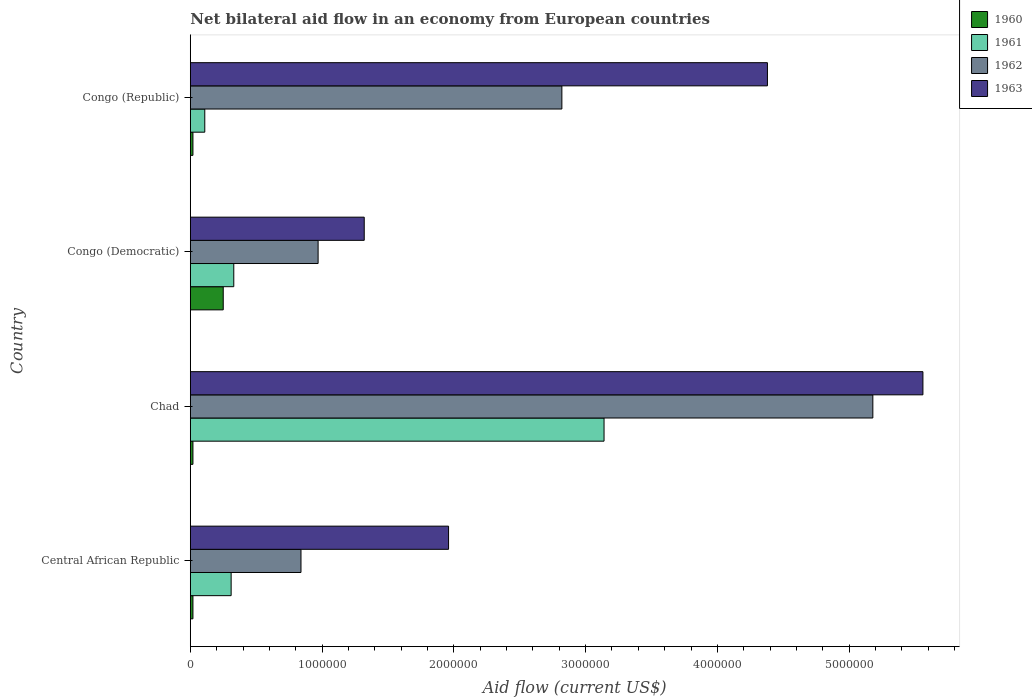How many different coloured bars are there?
Keep it short and to the point. 4. Are the number of bars per tick equal to the number of legend labels?
Your answer should be very brief. Yes. Are the number of bars on each tick of the Y-axis equal?
Provide a short and direct response. Yes. How many bars are there on the 3rd tick from the bottom?
Provide a short and direct response. 4. What is the label of the 4th group of bars from the top?
Offer a very short reply. Central African Republic. In how many cases, is the number of bars for a given country not equal to the number of legend labels?
Offer a very short reply. 0. What is the net bilateral aid flow in 1963 in Chad?
Make the answer very short. 5.56e+06. Across all countries, what is the maximum net bilateral aid flow in 1963?
Your response must be concise. 5.56e+06. Across all countries, what is the minimum net bilateral aid flow in 1960?
Provide a short and direct response. 2.00e+04. In which country was the net bilateral aid flow in 1961 maximum?
Your response must be concise. Chad. In which country was the net bilateral aid flow in 1962 minimum?
Your answer should be compact. Central African Republic. What is the total net bilateral aid flow in 1961 in the graph?
Your answer should be very brief. 3.89e+06. What is the difference between the net bilateral aid flow in 1962 in Congo (Democratic) and that in Congo (Republic)?
Keep it short and to the point. -1.85e+06. What is the difference between the net bilateral aid flow in 1962 in Congo (Republic) and the net bilateral aid flow in 1960 in Central African Republic?
Ensure brevity in your answer.  2.80e+06. What is the average net bilateral aid flow in 1962 per country?
Your response must be concise. 2.45e+06. What is the difference between the net bilateral aid flow in 1962 and net bilateral aid flow in 1960 in Congo (Democratic)?
Make the answer very short. 7.20e+05. In how many countries, is the net bilateral aid flow in 1960 greater than 5600000 US$?
Offer a very short reply. 0. What is the ratio of the net bilateral aid flow in 1962 in Chad to that in Congo (Democratic)?
Your response must be concise. 5.34. Is the difference between the net bilateral aid flow in 1962 in Central African Republic and Chad greater than the difference between the net bilateral aid flow in 1960 in Central African Republic and Chad?
Ensure brevity in your answer.  No. What is the difference between the highest and the second highest net bilateral aid flow in 1962?
Your answer should be very brief. 2.36e+06. What is the difference between the highest and the lowest net bilateral aid flow in 1961?
Your answer should be compact. 3.03e+06. In how many countries, is the net bilateral aid flow in 1962 greater than the average net bilateral aid flow in 1962 taken over all countries?
Give a very brief answer. 2. Is the sum of the net bilateral aid flow in 1960 in Central African Republic and Congo (Republic) greater than the maximum net bilateral aid flow in 1961 across all countries?
Offer a terse response. No. What does the 2nd bar from the bottom in Central African Republic represents?
Provide a succinct answer. 1961. Is it the case that in every country, the sum of the net bilateral aid flow in 1960 and net bilateral aid flow in 1963 is greater than the net bilateral aid flow in 1962?
Your answer should be very brief. Yes. How many countries are there in the graph?
Ensure brevity in your answer.  4. What is the difference between two consecutive major ticks on the X-axis?
Your answer should be very brief. 1.00e+06. Are the values on the major ticks of X-axis written in scientific E-notation?
Your answer should be very brief. No. Does the graph contain any zero values?
Offer a terse response. No. How many legend labels are there?
Your answer should be compact. 4. How are the legend labels stacked?
Make the answer very short. Vertical. What is the title of the graph?
Give a very brief answer. Net bilateral aid flow in an economy from European countries. Does "1967" appear as one of the legend labels in the graph?
Your answer should be compact. No. What is the Aid flow (current US$) of 1960 in Central African Republic?
Offer a very short reply. 2.00e+04. What is the Aid flow (current US$) in 1961 in Central African Republic?
Your answer should be very brief. 3.10e+05. What is the Aid flow (current US$) of 1962 in Central African Republic?
Offer a very short reply. 8.40e+05. What is the Aid flow (current US$) in 1963 in Central African Republic?
Give a very brief answer. 1.96e+06. What is the Aid flow (current US$) in 1961 in Chad?
Your answer should be compact. 3.14e+06. What is the Aid flow (current US$) of 1962 in Chad?
Provide a short and direct response. 5.18e+06. What is the Aid flow (current US$) in 1963 in Chad?
Your answer should be compact. 5.56e+06. What is the Aid flow (current US$) in 1960 in Congo (Democratic)?
Provide a succinct answer. 2.50e+05. What is the Aid flow (current US$) in 1961 in Congo (Democratic)?
Your answer should be compact. 3.30e+05. What is the Aid flow (current US$) of 1962 in Congo (Democratic)?
Provide a short and direct response. 9.70e+05. What is the Aid flow (current US$) of 1963 in Congo (Democratic)?
Ensure brevity in your answer.  1.32e+06. What is the Aid flow (current US$) in 1961 in Congo (Republic)?
Provide a short and direct response. 1.10e+05. What is the Aid flow (current US$) in 1962 in Congo (Republic)?
Your answer should be very brief. 2.82e+06. What is the Aid flow (current US$) of 1963 in Congo (Republic)?
Your answer should be very brief. 4.38e+06. Across all countries, what is the maximum Aid flow (current US$) in 1960?
Offer a very short reply. 2.50e+05. Across all countries, what is the maximum Aid flow (current US$) of 1961?
Your response must be concise. 3.14e+06. Across all countries, what is the maximum Aid flow (current US$) of 1962?
Your answer should be compact. 5.18e+06. Across all countries, what is the maximum Aid flow (current US$) of 1963?
Keep it short and to the point. 5.56e+06. Across all countries, what is the minimum Aid flow (current US$) in 1960?
Keep it short and to the point. 2.00e+04. Across all countries, what is the minimum Aid flow (current US$) in 1961?
Ensure brevity in your answer.  1.10e+05. Across all countries, what is the minimum Aid flow (current US$) of 1962?
Ensure brevity in your answer.  8.40e+05. Across all countries, what is the minimum Aid flow (current US$) in 1963?
Ensure brevity in your answer.  1.32e+06. What is the total Aid flow (current US$) of 1961 in the graph?
Keep it short and to the point. 3.89e+06. What is the total Aid flow (current US$) of 1962 in the graph?
Offer a very short reply. 9.81e+06. What is the total Aid flow (current US$) in 1963 in the graph?
Offer a terse response. 1.32e+07. What is the difference between the Aid flow (current US$) in 1960 in Central African Republic and that in Chad?
Your answer should be compact. 0. What is the difference between the Aid flow (current US$) of 1961 in Central African Republic and that in Chad?
Keep it short and to the point. -2.83e+06. What is the difference between the Aid flow (current US$) in 1962 in Central African Republic and that in Chad?
Keep it short and to the point. -4.34e+06. What is the difference between the Aid flow (current US$) in 1963 in Central African Republic and that in Chad?
Your answer should be compact. -3.60e+06. What is the difference between the Aid flow (current US$) of 1961 in Central African Republic and that in Congo (Democratic)?
Ensure brevity in your answer.  -2.00e+04. What is the difference between the Aid flow (current US$) of 1962 in Central African Republic and that in Congo (Democratic)?
Ensure brevity in your answer.  -1.30e+05. What is the difference between the Aid flow (current US$) of 1963 in Central African Republic and that in Congo (Democratic)?
Make the answer very short. 6.40e+05. What is the difference between the Aid flow (current US$) in 1960 in Central African Republic and that in Congo (Republic)?
Your answer should be very brief. 0. What is the difference between the Aid flow (current US$) of 1962 in Central African Republic and that in Congo (Republic)?
Offer a very short reply. -1.98e+06. What is the difference between the Aid flow (current US$) of 1963 in Central African Republic and that in Congo (Republic)?
Your answer should be very brief. -2.42e+06. What is the difference between the Aid flow (current US$) in 1960 in Chad and that in Congo (Democratic)?
Ensure brevity in your answer.  -2.30e+05. What is the difference between the Aid flow (current US$) of 1961 in Chad and that in Congo (Democratic)?
Ensure brevity in your answer.  2.81e+06. What is the difference between the Aid flow (current US$) of 1962 in Chad and that in Congo (Democratic)?
Ensure brevity in your answer.  4.21e+06. What is the difference between the Aid flow (current US$) in 1963 in Chad and that in Congo (Democratic)?
Give a very brief answer. 4.24e+06. What is the difference between the Aid flow (current US$) of 1961 in Chad and that in Congo (Republic)?
Offer a terse response. 3.03e+06. What is the difference between the Aid flow (current US$) in 1962 in Chad and that in Congo (Republic)?
Offer a very short reply. 2.36e+06. What is the difference between the Aid flow (current US$) in 1963 in Chad and that in Congo (Republic)?
Make the answer very short. 1.18e+06. What is the difference between the Aid flow (current US$) of 1961 in Congo (Democratic) and that in Congo (Republic)?
Your answer should be very brief. 2.20e+05. What is the difference between the Aid flow (current US$) of 1962 in Congo (Democratic) and that in Congo (Republic)?
Ensure brevity in your answer.  -1.85e+06. What is the difference between the Aid flow (current US$) of 1963 in Congo (Democratic) and that in Congo (Republic)?
Make the answer very short. -3.06e+06. What is the difference between the Aid flow (current US$) of 1960 in Central African Republic and the Aid flow (current US$) of 1961 in Chad?
Keep it short and to the point. -3.12e+06. What is the difference between the Aid flow (current US$) in 1960 in Central African Republic and the Aid flow (current US$) in 1962 in Chad?
Your response must be concise. -5.16e+06. What is the difference between the Aid flow (current US$) in 1960 in Central African Republic and the Aid flow (current US$) in 1963 in Chad?
Ensure brevity in your answer.  -5.54e+06. What is the difference between the Aid flow (current US$) of 1961 in Central African Republic and the Aid flow (current US$) of 1962 in Chad?
Ensure brevity in your answer.  -4.87e+06. What is the difference between the Aid flow (current US$) in 1961 in Central African Republic and the Aid flow (current US$) in 1963 in Chad?
Your answer should be very brief. -5.25e+06. What is the difference between the Aid flow (current US$) of 1962 in Central African Republic and the Aid flow (current US$) of 1963 in Chad?
Provide a succinct answer. -4.72e+06. What is the difference between the Aid flow (current US$) of 1960 in Central African Republic and the Aid flow (current US$) of 1961 in Congo (Democratic)?
Your answer should be compact. -3.10e+05. What is the difference between the Aid flow (current US$) of 1960 in Central African Republic and the Aid flow (current US$) of 1962 in Congo (Democratic)?
Your answer should be compact. -9.50e+05. What is the difference between the Aid flow (current US$) in 1960 in Central African Republic and the Aid flow (current US$) in 1963 in Congo (Democratic)?
Provide a succinct answer. -1.30e+06. What is the difference between the Aid flow (current US$) of 1961 in Central African Republic and the Aid flow (current US$) of 1962 in Congo (Democratic)?
Your answer should be compact. -6.60e+05. What is the difference between the Aid flow (current US$) of 1961 in Central African Republic and the Aid flow (current US$) of 1963 in Congo (Democratic)?
Keep it short and to the point. -1.01e+06. What is the difference between the Aid flow (current US$) in 1962 in Central African Republic and the Aid flow (current US$) in 1963 in Congo (Democratic)?
Keep it short and to the point. -4.80e+05. What is the difference between the Aid flow (current US$) of 1960 in Central African Republic and the Aid flow (current US$) of 1962 in Congo (Republic)?
Keep it short and to the point. -2.80e+06. What is the difference between the Aid flow (current US$) of 1960 in Central African Republic and the Aid flow (current US$) of 1963 in Congo (Republic)?
Give a very brief answer. -4.36e+06. What is the difference between the Aid flow (current US$) of 1961 in Central African Republic and the Aid flow (current US$) of 1962 in Congo (Republic)?
Keep it short and to the point. -2.51e+06. What is the difference between the Aid flow (current US$) of 1961 in Central African Republic and the Aid flow (current US$) of 1963 in Congo (Republic)?
Give a very brief answer. -4.07e+06. What is the difference between the Aid flow (current US$) in 1962 in Central African Republic and the Aid flow (current US$) in 1963 in Congo (Republic)?
Offer a terse response. -3.54e+06. What is the difference between the Aid flow (current US$) in 1960 in Chad and the Aid flow (current US$) in 1961 in Congo (Democratic)?
Your answer should be very brief. -3.10e+05. What is the difference between the Aid flow (current US$) of 1960 in Chad and the Aid flow (current US$) of 1962 in Congo (Democratic)?
Your answer should be compact. -9.50e+05. What is the difference between the Aid flow (current US$) of 1960 in Chad and the Aid flow (current US$) of 1963 in Congo (Democratic)?
Provide a short and direct response. -1.30e+06. What is the difference between the Aid flow (current US$) in 1961 in Chad and the Aid flow (current US$) in 1962 in Congo (Democratic)?
Keep it short and to the point. 2.17e+06. What is the difference between the Aid flow (current US$) of 1961 in Chad and the Aid flow (current US$) of 1963 in Congo (Democratic)?
Provide a short and direct response. 1.82e+06. What is the difference between the Aid flow (current US$) of 1962 in Chad and the Aid flow (current US$) of 1963 in Congo (Democratic)?
Provide a succinct answer. 3.86e+06. What is the difference between the Aid flow (current US$) of 1960 in Chad and the Aid flow (current US$) of 1961 in Congo (Republic)?
Give a very brief answer. -9.00e+04. What is the difference between the Aid flow (current US$) of 1960 in Chad and the Aid flow (current US$) of 1962 in Congo (Republic)?
Make the answer very short. -2.80e+06. What is the difference between the Aid flow (current US$) of 1960 in Chad and the Aid flow (current US$) of 1963 in Congo (Republic)?
Your answer should be compact. -4.36e+06. What is the difference between the Aid flow (current US$) in 1961 in Chad and the Aid flow (current US$) in 1962 in Congo (Republic)?
Your answer should be very brief. 3.20e+05. What is the difference between the Aid flow (current US$) in 1961 in Chad and the Aid flow (current US$) in 1963 in Congo (Republic)?
Give a very brief answer. -1.24e+06. What is the difference between the Aid flow (current US$) in 1960 in Congo (Democratic) and the Aid flow (current US$) in 1962 in Congo (Republic)?
Provide a succinct answer. -2.57e+06. What is the difference between the Aid flow (current US$) in 1960 in Congo (Democratic) and the Aid flow (current US$) in 1963 in Congo (Republic)?
Your answer should be compact. -4.13e+06. What is the difference between the Aid flow (current US$) in 1961 in Congo (Democratic) and the Aid flow (current US$) in 1962 in Congo (Republic)?
Your answer should be very brief. -2.49e+06. What is the difference between the Aid flow (current US$) in 1961 in Congo (Democratic) and the Aid flow (current US$) in 1963 in Congo (Republic)?
Offer a terse response. -4.05e+06. What is the difference between the Aid flow (current US$) in 1962 in Congo (Democratic) and the Aid flow (current US$) in 1963 in Congo (Republic)?
Offer a very short reply. -3.41e+06. What is the average Aid flow (current US$) of 1960 per country?
Offer a very short reply. 7.75e+04. What is the average Aid flow (current US$) in 1961 per country?
Your response must be concise. 9.72e+05. What is the average Aid flow (current US$) in 1962 per country?
Your answer should be very brief. 2.45e+06. What is the average Aid flow (current US$) of 1963 per country?
Your answer should be very brief. 3.30e+06. What is the difference between the Aid flow (current US$) in 1960 and Aid flow (current US$) in 1962 in Central African Republic?
Offer a very short reply. -8.20e+05. What is the difference between the Aid flow (current US$) of 1960 and Aid flow (current US$) of 1963 in Central African Republic?
Keep it short and to the point. -1.94e+06. What is the difference between the Aid flow (current US$) in 1961 and Aid flow (current US$) in 1962 in Central African Republic?
Provide a short and direct response. -5.30e+05. What is the difference between the Aid flow (current US$) of 1961 and Aid flow (current US$) of 1963 in Central African Republic?
Your answer should be compact. -1.65e+06. What is the difference between the Aid flow (current US$) in 1962 and Aid flow (current US$) in 1963 in Central African Republic?
Make the answer very short. -1.12e+06. What is the difference between the Aid flow (current US$) of 1960 and Aid flow (current US$) of 1961 in Chad?
Your response must be concise. -3.12e+06. What is the difference between the Aid flow (current US$) in 1960 and Aid flow (current US$) in 1962 in Chad?
Keep it short and to the point. -5.16e+06. What is the difference between the Aid flow (current US$) in 1960 and Aid flow (current US$) in 1963 in Chad?
Your answer should be very brief. -5.54e+06. What is the difference between the Aid flow (current US$) in 1961 and Aid flow (current US$) in 1962 in Chad?
Provide a succinct answer. -2.04e+06. What is the difference between the Aid flow (current US$) of 1961 and Aid flow (current US$) of 1963 in Chad?
Provide a short and direct response. -2.42e+06. What is the difference between the Aid flow (current US$) in 1962 and Aid flow (current US$) in 1963 in Chad?
Provide a succinct answer. -3.80e+05. What is the difference between the Aid flow (current US$) of 1960 and Aid flow (current US$) of 1961 in Congo (Democratic)?
Your answer should be very brief. -8.00e+04. What is the difference between the Aid flow (current US$) of 1960 and Aid flow (current US$) of 1962 in Congo (Democratic)?
Your response must be concise. -7.20e+05. What is the difference between the Aid flow (current US$) in 1960 and Aid flow (current US$) in 1963 in Congo (Democratic)?
Make the answer very short. -1.07e+06. What is the difference between the Aid flow (current US$) of 1961 and Aid flow (current US$) of 1962 in Congo (Democratic)?
Offer a very short reply. -6.40e+05. What is the difference between the Aid flow (current US$) of 1961 and Aid flow (current US$) of 1963 in Congo (Democratic)?
Make the answer very short. -9.90e+05. What is the difference between the Aid flow (current US$) of 1962 and Aid flow (current US$) of 1963 in Congo (Democratic)?
Your answer should be very brief. -3.50e+05. What is the difference between the Aid flow (current US$) of 1960 and Aid flow (current US$) of 1961 in Congo (Republic)?
Your response must be concise. -9.00e+04. What is the difference between the Aid flow (current US$) in 1960 and Aid flow (current US$) in 1962 in Congo (Republic)?
Your answer should be very brief. -2.80e+06. What is the difference between the Aid flow (current US$) in 1960 and Aid flow (current US$) in 1963 in Congo (Republic)?
Offer a very short reply. -4.36e+06. What is the difference between the Aid flow (current US$) of 1961 and Aid flow (current US$) of 1962 in Congo (Republic)?
Your answer should be compact. -2.71e+06. What is the difference between the Aid flow (current US$) of 1961 and Aid flow (current US$) of 1963 in Congo (Republic)?
Make the answer very short. -4.27e+06. What is the difference between the Aid flow (current US$) in 1962 and Aid flow (current US$) in 1963 in Congo (Republic)?
Make the answer very short. -1.56e+06. What is the ratio of the Aid flow (current US$) in 1961 in Central African Republic to that in Chad?
Offer a terse response. 0.1. What is the ratio of the Aid flow (current US$) of 1962 in Central African Republic to that in Chad?
Provide a succinct answer. 0.16. What is the ratio of the Aid flow (current US$) in 1963 in Central African Republic to that in Chad?
Make the answer very short. 0.35. What is the ratio of the Aid flow (current US$) in 1960 in Central African Republic to that in Congo (Democratic)?
Ensure brevity in your answer.  0.08. What is the ratio of the Aid flow (current US$) in 1961 in Central African Republic to that in Congo (Democratic)?
Give a very brief answer. 0.94. What is the ratio of the Aid flow (current US$) of 1962 in Central African Republic to that in Congo (Democratic)?
Your answer should be very brief. 0.87. What is the ratio of the Aid flow (current US$) in 1963 in Central African Republic to that in Congo (Democratic)?
Your answer should be very brief. 1.48. What is the ratio of the Aid flow (current US$) of 1961 in Central African Republic to that in Congo (Republic)?
Ensure brevity in your answer.  2.82. What is the ratio of the Aid flow (current US$) of 1962 in Central African Republic to that in Congo (Republic)?
Your response must be concise. 0.3. What is the ratio of the Aid flow (current US$) of 1963 in Central African Republic to that in Congo (Republic)?
Keep it short and to the point. 0.45. What is the ratio of the Aid flow (current US$) in 1960 in Chad to that in Congo (Democratic)?
Offer a very short reply. 0.08. What is the ratio of the Aid flow (current US$) in 1961 in Chad to that in Congo (Democratic)?
Offer a very short reply. 9.52. What is the ratio of the Aid flow (current US$) of 1962 in Chad to that in Congo (Democratic)?
Your answer should be very brief. 5.34. What is the ratio of the Aid flow (current US$) in 1963 in Chad to that in Congo (Democratic)?
Ensure brevity in your answer.  4.21. What is the ratio of the Aid flow (current US$) of 1960 in Chad to that in Congo (Republic)?
Give a very brief answer. 1. What is the ratio of the Aid flow (current US$) in 1961 in Chad to that in Congo (Republic)?
Offer a terse response. 28.55. What is the ratio of the Aid flow (current US$) in 1962 in Chad to that in Congo (Republic)?
Your answer should be very brief. 1.84. What is the ratio of the Aid flow (current US$) in 1963 in Chad to that in Congo (Republic)?
Your answer should be compact. 1.27. What is the ratio of the Aid flow (current US$) in 1962 in Congo (Democratic) to that in Congo (Republic)?
Give a very brief answer. 0.34. What is the ratio of the Aid flow (current US$) of 1963 in Congo (Democratic) to that in Congo (Republic)?
Your answer should be compact. 0.3. What is the difference between the highest and the second highest Aid flow (current US$) of 1961?
Ensure brevity in your answer.  2.81e+06. What is the difference between the highest and the second highest Aid flow (current US$) in 1962?
Offer a terse response. 2.36e+06. What is the difference between the highest and the second highest Aid flow (current US$) of 1963?
Make the answer very short. 1.18e+06. What is the difference between the highest and the lowest Aid flow (current US$) of 1960?
Keep it short and to the point. 2.30e+05. What is the difference between the highest and the lowest Aid flow (current US$) in 1961?
Give a very brief answer. 3.03e+06. What is the difference between the highest and the lowest Aid flow (current US$) in 1962?
Make the answer very short. 4.34e+06. What is the difference between the highest and the lowest Aid flow (current US$) of 1963?
Make the answer very short. 4.24e+06. 